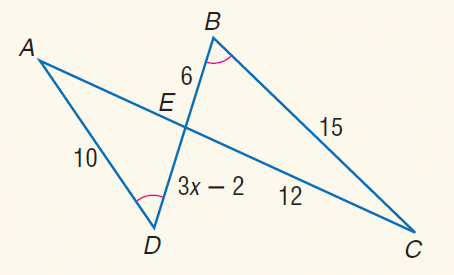Answer the mathemtical geometry problem and directly provide the correct option letter.
Question: Find A E.
Choices: A: 6 B: 7 C: 8 D: 9 C 